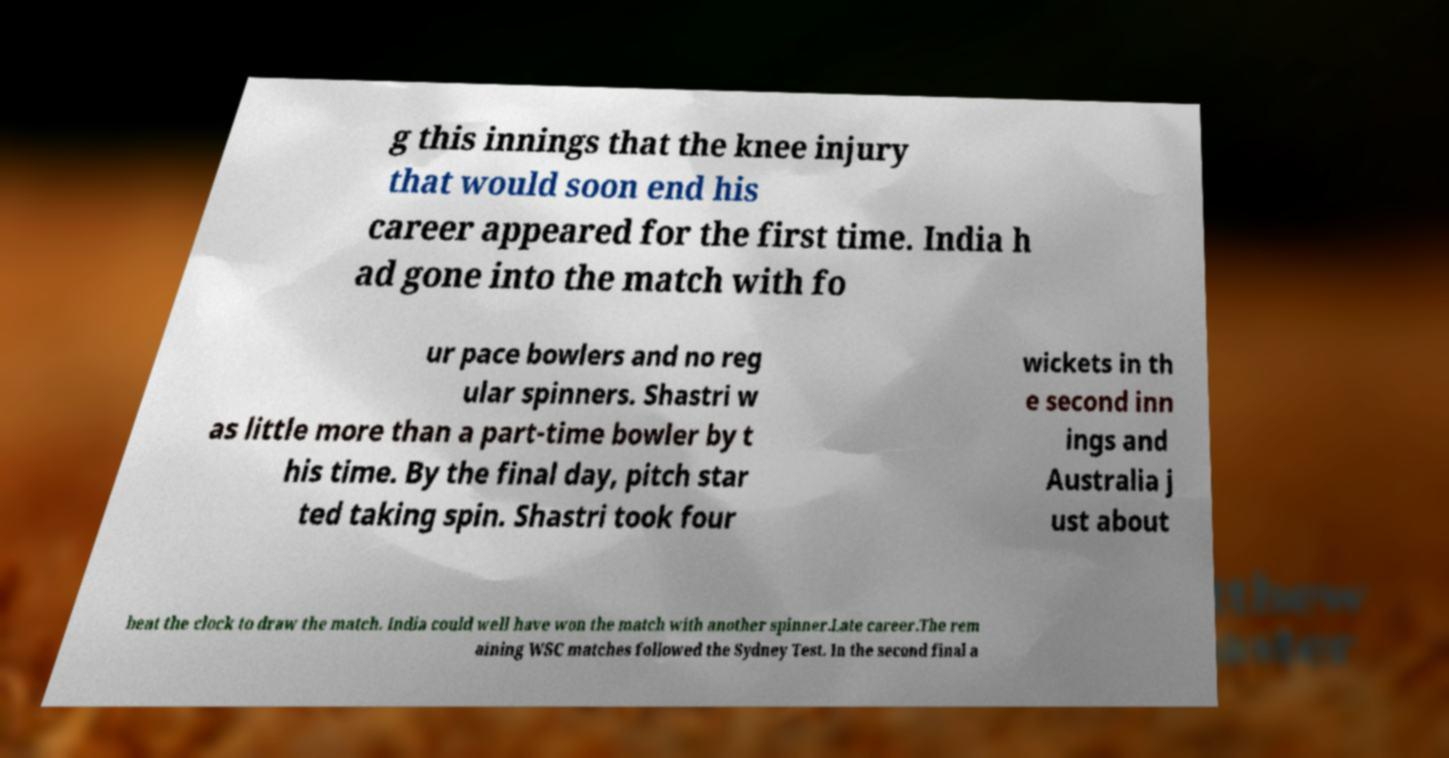There's text embedded in this image that I need extracted. Can you transcribe it verbatim? g this innings that the knee injury that would soon end his career appeared for the first time. India h ad gone into the match with fo ur pace bowlers and no reg ular spinners. Shastri w as little more than a part-time bowler by t his time. By the final day, pitch star ted taking spin. Shastri took four wickets in th e second inn ings and Australia j ust about beat the clock to draw the match. India could well have won the match with another spinner.Late career.The rem aining WSC matches followed the Sydney Test. In the second final a 